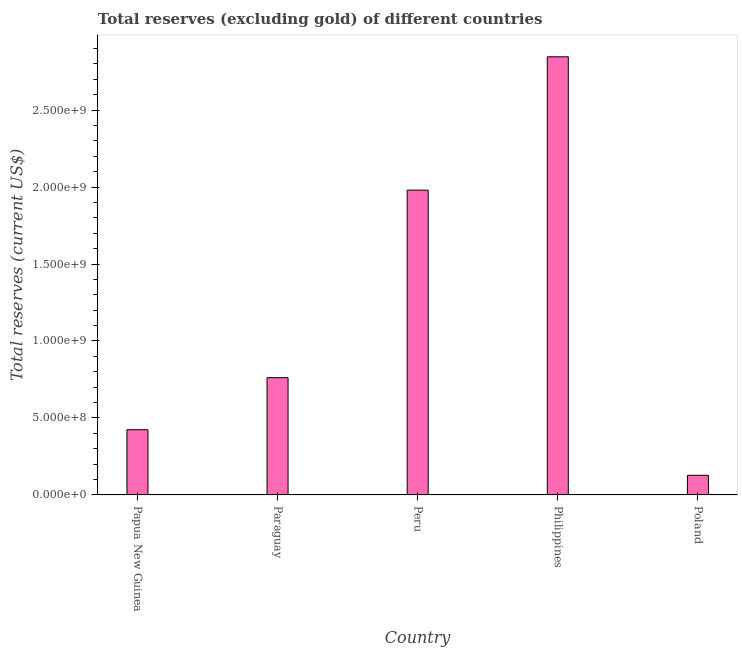What is the title of the graph?
Make the answer very short. Total reserves (excluding gold) of different countries. What is the label or title of the X-axis?
Offer a very short reply. Country. What is the label or title of the Y-axis?
Provide a short and direct response. Total reserves (current US$). What is the total reserves (excluding gold) in Philippines?
Provide a succinct answer. 2.85e+09. Across all countries, what is the maximum total reserves (excluding gold)?
Keep it short and to the point. 2.85e+09. Across all countries, what is the minimum total reserves (excluding gold)?
Your answer should be compact. 1.28e+08. In which country was the total reserves (excluding gold) maximum?
Make the answer very short. Philippines. What is the sum of the total reserves (excluding gold)?
Your answer should be compact. 6.14e+09. What is the difference between the total reserves (excluding gold) in Papua New Guinea and Philippines?
Give a very brief answer. -2.42e+09. What is the average total reserves (excluding gold) per country?
Your response must be concise. 1.23e+09. What is the median total reserves (excluding gold)?
Make the answer very short. 7.62e+08. What is the ratio of the total reserves (excluding gold) in Papua New Guinea to that in Philippines?
Keep it short and to the point. 0.15. Is the total reserves (excluding gold) in Papua New Guinea less than that in Peru?
Offer a very short reply. Yes. Is the difference between the total reserves (excluding gold) in Philippines and Poland greater than the difference between any two countries?
Provide a short and direct response. Yes. What is the difference between the highest and the second highest total reserves (excluding gold)?
Ensure brevity in your answer.  8.66e+08. What is the difference between the highest and the lowest total reserves (excluding gold)?
Offer a terse response. 2.72e+09. In how many countries, is the total reserves (excluding gold) greater than the average total reserves (excluding gold) taken over all countries?
Provide a succinct answer. 2. How many countries are there in the graph?
Offer a very short reply. 5. Are the values on the major ticks of Y-axis written in scientific E-notation?
Your response must be concise. Yes. What is the Total reserves (current US$) in Papua New Guinea?
Your answer should be very brief. 4.23e+08. What is the Total reserves (current US$) in Paraguay?
Offer a very short reply. 7.62e+08. What is the Total reserves (current US$) in Peru?
Ensure brevity in your answer.  1.98e+09. What is the Total reserves (current US$) of Philippines?
Provide a short and direct response. 2.85e+09. What is the Total reserves (current US$) in Poland?
Your response must be concise. 1.28e+08. What is the difference between the Total reserves (current US$) in Papua New Guinea and Paraguay?
Make the answer very short. -3.38e+08. What is the difference between the Total reserves (current US$) in Papua New Guinea and Peru?
Give a very brief answer. -1.56e+09. What is the difference between the Total reserves (current US$) in Papua New Guinea and Philippines?
Ensure brevity in your answer.  -2.42e+09. What is the difference between the Total reserves (current US$) in Papua New Guinea and Poland?
Your answer should be compact. 2.96e+08. What is the difference between the Total reserves (current US$) in Paraguay and Peru?
Make the answer very short. -1.22e+09. What is the difference between the Total reserves (current US$) in Paraguay and Philippines?
Make the answer very short. -2.08e+09. What is the difference between the Total reserves (current US$) in Paraguay and Poland?
Provide a succinct answer. 6.34e+08. What is the difference between the Total reserves (current US$) in Peru and Philippines?
Provide a short and direct response. -8.66e+08. What is the difference between the Total reserves (current US$) in Peru and Poland?
Your response must be concise. 1.85e+09. What is the difference between the Total reserves (current US$) in Philippines and Poland?
Your response must be concise. 2.72e+09. What is the ratio of the Total reserves (current US$) in Papua New Guinea to that in Paraguay?
Provide a succinct answer. 0.56. What is the ratio of the Total reserves (current US$) in Papua New Guinea to that in Peru?
Offer a very short reply. 0.21. What is the ratio of the Total reserves (current US$) in Papua New Guinea to that in Philippines?
Your answer should be very brief. 0.15. What is the ratio of the Total reserves (current US$) in Papua New Guinea to that in Poland?
Ensure brevity in your answer.  3.32. What is the ratio of the Total reserves (current US$) in Paraguay to that in Peru?
Ensure brevity in your answer.  0.39. What is the ratio of the Total reserves (current US$) in Paraguay to that in Philippines?
Keep it short and to the point. 0.27. What is the ratio of the Total reserves (current US$) in Paraguay to that in Poland?
Offer a very short reply. 5.97. What is the ratio of the Total reserves (current US$) in Peru to that in Philippines?
Ensure brevity in your answer.  0.7. What is the ratio of the Total reserves (current US$) in Peru to that in Poland?
Your response must be concise. 15.52. What is the ratio of the Total reserves (current US$) in Philippines to that in Poland?
Ensure brevity in your answer.  22.3. 